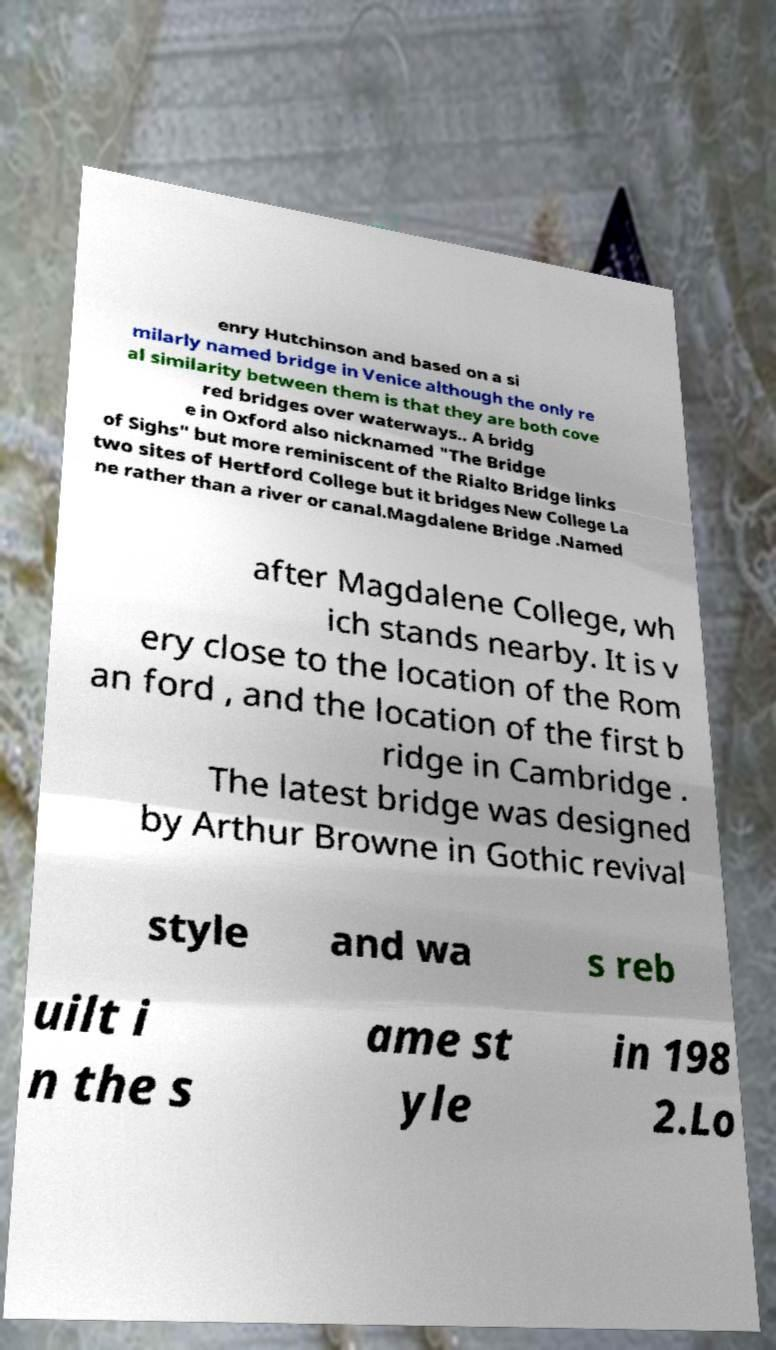Can you accurately transcribe the text from the provided image for me? enry Hutchinson and based on a si milarly named bridge in Venice although the only re al similarity between them is that they are both cove red bridges over waterways.. A bridg e in Oxford also nicknamed "The Bridge of Sighs" but more reminiscent of the Rialto Bridge links two sites of Hertford College but it bridges New College La ne rather than a river or canal.Magdalene Bridge .Named after Magdalene College, wh ich stands nearby. It is v ery close to the location of the Rom an ford , and the location of the first b ridge in Cambridge . The latest bridge was designed by Arthur Browne in Gothic revival style and wa s reb uilt i n the s ame st yle in 198 2.Lo 